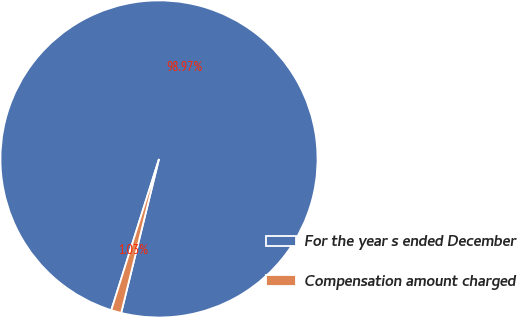Convert chart to OTSL. <chart><loc_0><loc_0><loc_500><loc_500><pie_chart><fcel>For the year s ended December<fcel>Compensation amount charged<nl><fcel>98.97%<fcel>1.03%<nl></chart> 